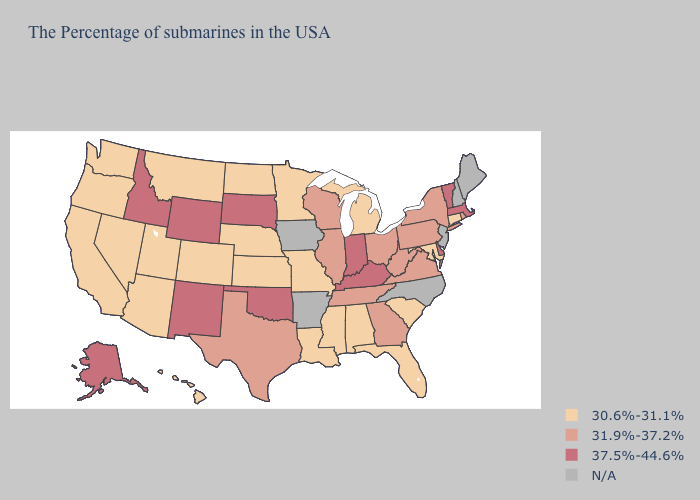Does Mississippi have the lowest value in the USA?
Quick response, please. Yes. Name the states that have a value in the range 37.5%-44.6%?
Short answer required. Massachusetts, Vermont, Delaware, Kentucky, Indiana, Oklahoma, South Dakota, Wyoming, New Mexico, Idaho, Alaska. Among the states that border West Virginia , which have the highest value?
Short answer required. Kentucky. Does the first symbol in the legend represent the smallest category?
Be succinct. Yes. Does Idaho have the lowest value in the West?
Give a very brief answer. No. What is the value of New Hampshire?
Keep it brief. N/A. Which states have the highest value in the USA?
Be succinct. Massachusetts, Vermont, Delaware, Kentucky, Indiana, Oklahoma, South Dakota, Wyoming, New Mexico, Idaho, Alaska. What is the value of North Carolina?
Quick response, please. N/A. Among the states that border Idaho , which have the lowest value?
Give a very brief answer. Utah, Montana, Nevada, Washington, Oregon. What is the value of Louisiana?
Keep it brief. 30.6%-31.1%. What is the value of Arizona?
Keep it brief. 30.6%-31.1%. Among the states that border Arizona , does Colorado have the highest value?
Write a very short answer. No. What is the value of Kansas?
Give a very brief answer. 30.6%-31.1%. Name the states that have a value in the range 31.9%-37.2%?
Give a very brief answer. Rhode Island, New York, Pennsylvania, Virginia, West Virginia, Ohio, Georgia, Tennessee, Wisconsin, Illinois, Texas. 